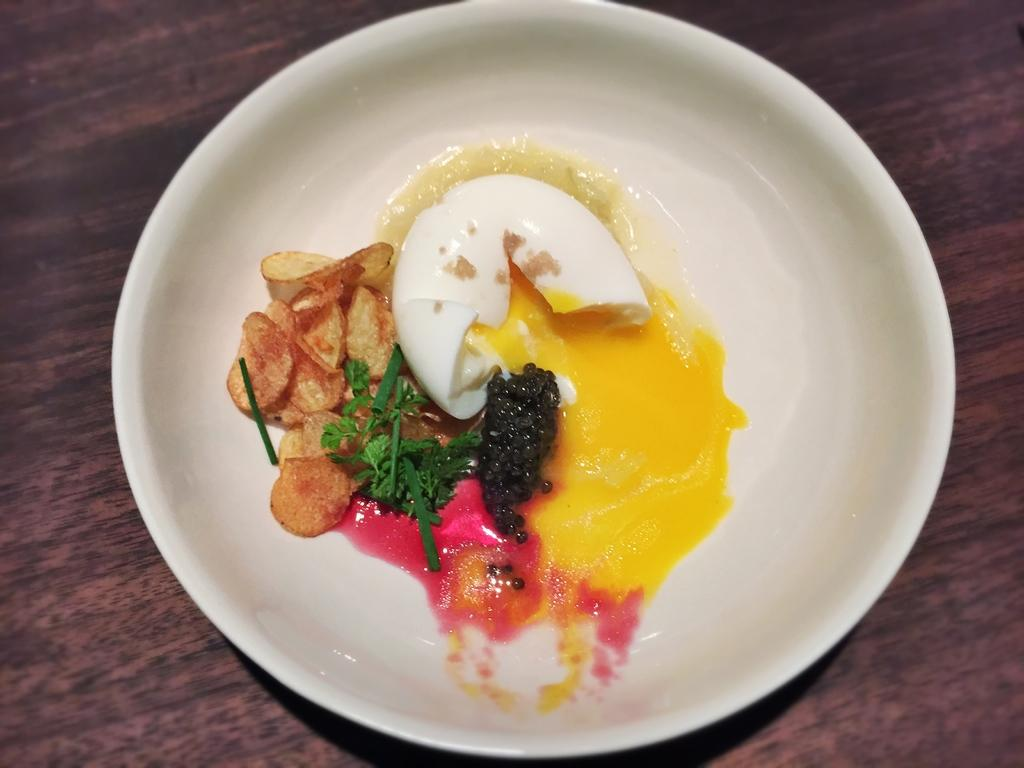What is on the plate in the image? There is food in the plate in the image. What type of table is visible in the image? There is a wooden table in the image. What type of hat is the person wearing in the image? There is no person or hat present in the image; it only features a plate of food on a wooden table. 